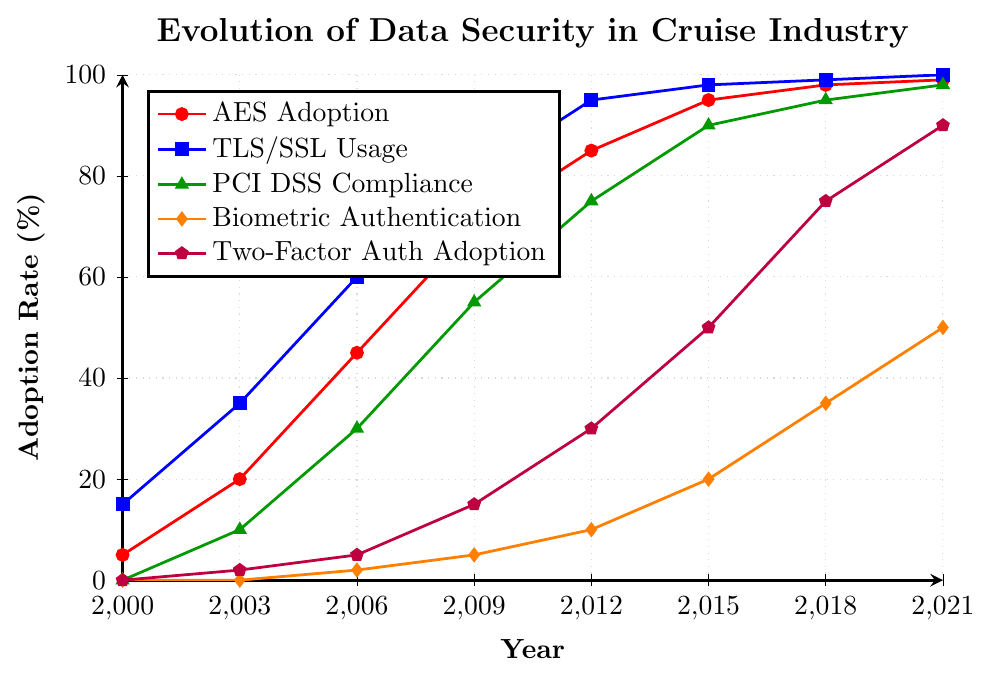What were the adoption rates of AES and Biometric Authentication in 2012? Look at the points on the line with title "AES Adoption" and "Biometric Authentication" at x=2012. AES Adoption was 85% and Biometric Authentication was 10%.
Answer: AES: 85%, Biometric Authentication: 10% In which year did PCI DSS Compliance and Two-Factor Authentication both exceed 70%? Trace the points along the lines titled "PCI DSS Compliance" and "Two-Factor Authentication" to find the year where both percentages are higher than 70%. Both exceed 70% in 2015.
Answer: 2015 Compare the adoption rate of TLS/SSL Usage between 2009 and 2012. How much did it increase? Find the points on the "TLS/SSL Usage" line at x=2009 and x=2012. The adoption rate increased from 80% in 2009 to 95% in 2012, which is an increase of 15%.
Answer: 15% In which years did Biometric Authentication increase the most rapidly? Observe the slope of the "Biometric Authentication" line. The largest slopes (most rapid increase) appear between 2015 to 2018, and 2018 to 2021.
Answer: 2015-2018, 2018-2021 Which security measure had the highest adoption rate in 2021? Identify the point with the highest y-value in 2021. "TLS/SSL Usage" hits 100% in 2021, which is the highest.
Answer: TLS/SSL Usage By how much did the Two-Factor Authentication adoption rate increase between 2000 and 2018? Find the y-values of the "Two-Factor Auth Adoption" line at x=2000 and x=2018. The rate increased from 0% in 2000 to 75% in 2018. The increase is 75% - 0% = 75%.
Answer: 75% Which security measure showed no adoption before 2003 and what is its adoption rate in 2021? Track the lines before 2003. "Biometric Authentication" shows no adoption before 2003 and has an adoption rate of 50% in 2021.
Answer: Biometric Authentication, 50% Is there any year when all five security measures showed significant increments from the previous recorded year? Compare the increments of all lines across adjacent years. 2003 shows significant increments across AES Adoption, TLS/SSL Usage, PCI DSS Compliance, and Two-Factor Auth Adoption. However, 2018 and 2021 show significant increments in most measures with noticeable increments. The most consistent year is 2003.
Answer: 2003 